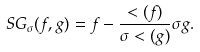Convert formula to latex. <formula><loc_0><loc_0><loc_500><loc_500>S G _ { \sigma } ( f , g ) = f - \frac { < ( f ) } { \sigma < ( g ) } \sigma g .</formula> 